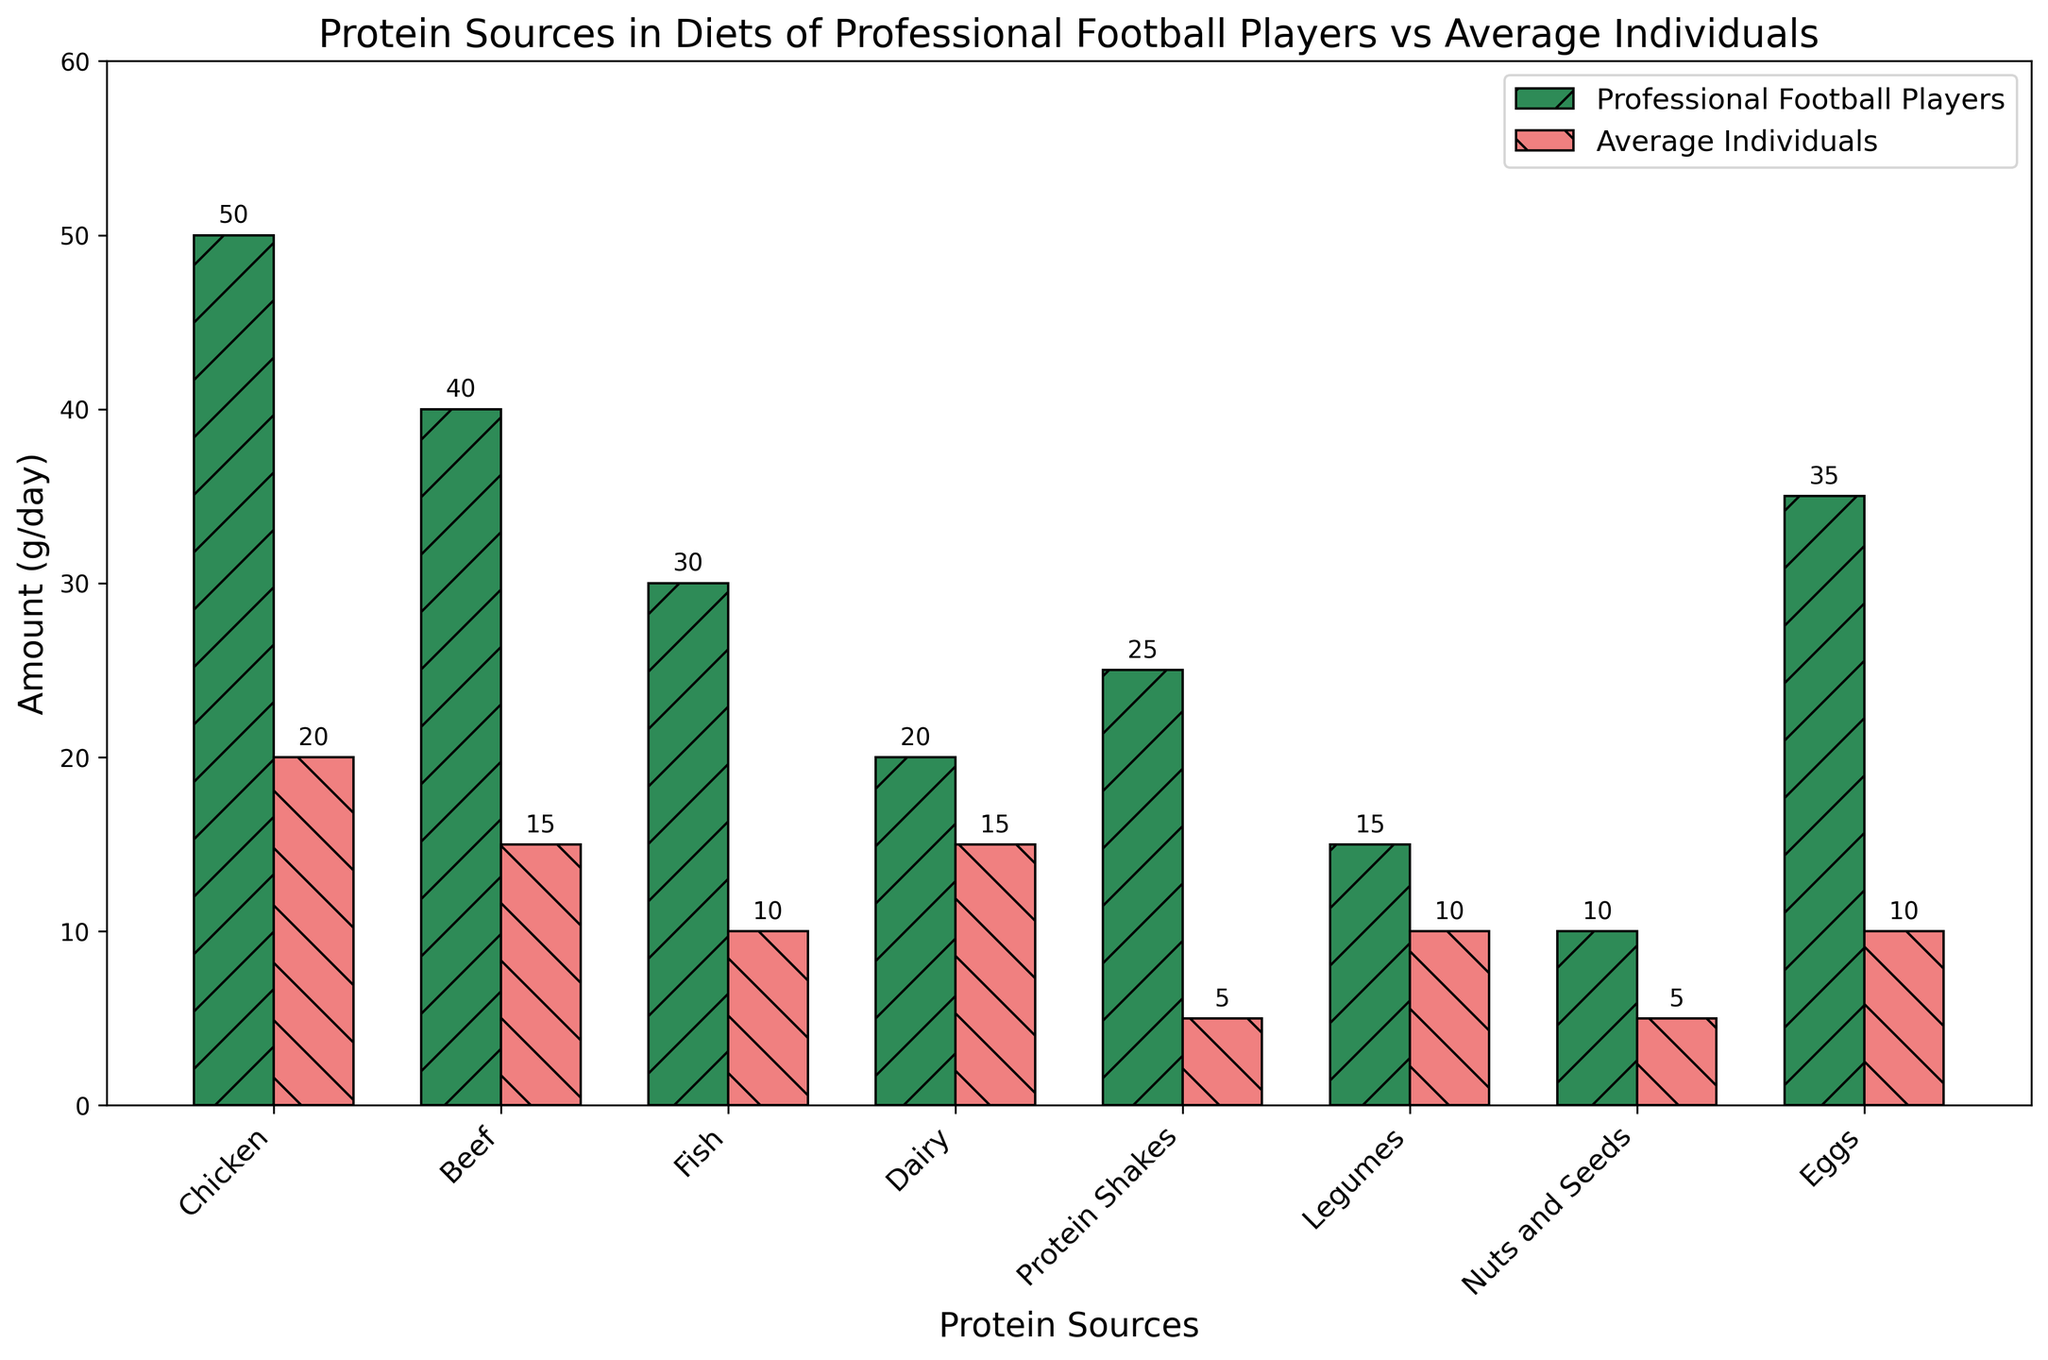What is the most consumed protein source by professional football players? By observing the height of the bars in the chart, the bar representing "Chicken" for professional football players is the tallest, indicating it is the most consumed protein source.
Answer: Chicken Which protein source is consumed more by average individuals than professional football players? By comparing the height of the bars for each protein source, "Dairy" is consumed more by average individuals (15g/day) than by professional football players (20g/day).
Answer: Dairy What is the total amount of protein consumed by professional football players? Sum the heights of all bars corresponding to professional football players: 50 (Chicken) + 40 (Beef) + 30 (Fish) + 20 (Dairy) + 25 (Protein Shakes) + 15 (Legumes) + 10 (Nuts and Seeds) + 35 (Eggs) = 225.
Answer: 225 g/day How much more chicken do professional football players consume compared to average individuals? Subtract the amount of chicken consumed by average individuals from the amount consumed by professional football players: 50g/day - 20g/day = 30g/day.
Answer: 30 g/day Which protein source shows the smallest difference in consumption between professional football players and average individuals? By visually comparing the bars, "Legumes" shows the smallest difference as professional football players consume 15g/day and average individuals consume 10g/day, difference is 5g/day.
Answer: Legumes Are protein shakes consumed more by professional football players or average individuals? By comparing the height of the bars representing protein shakes, the bar for professional football players is taller (25g/day) than that for average individuals (5g/day).
Answer: Professional football players How much protein from beef and fish combined is consumed by average individuals? Sum the amounts of beef and fish consumed by average individuals: 15g/day (Beef) + 10g/day (Fish) = 25g/day.
Answer: 25 g/day What is the average amount of protein from eggs consumed by both groups? Average the amounts from both groups: (35g/day + 10g/day) / 2 = 22.5g/day.
Answer: 22.5 g/day 